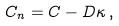Convert formula to latex. <formula><loc_0><loc_0><loc_500><loc_500>C _ { n } = C - D \kappa \, ,</formula> 